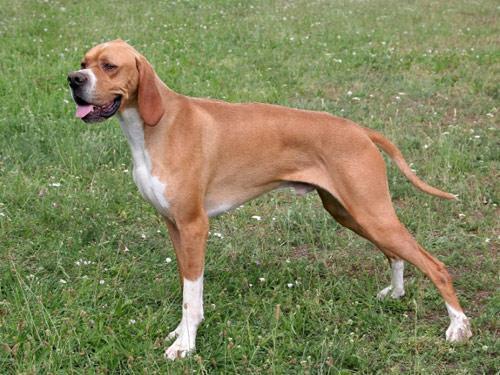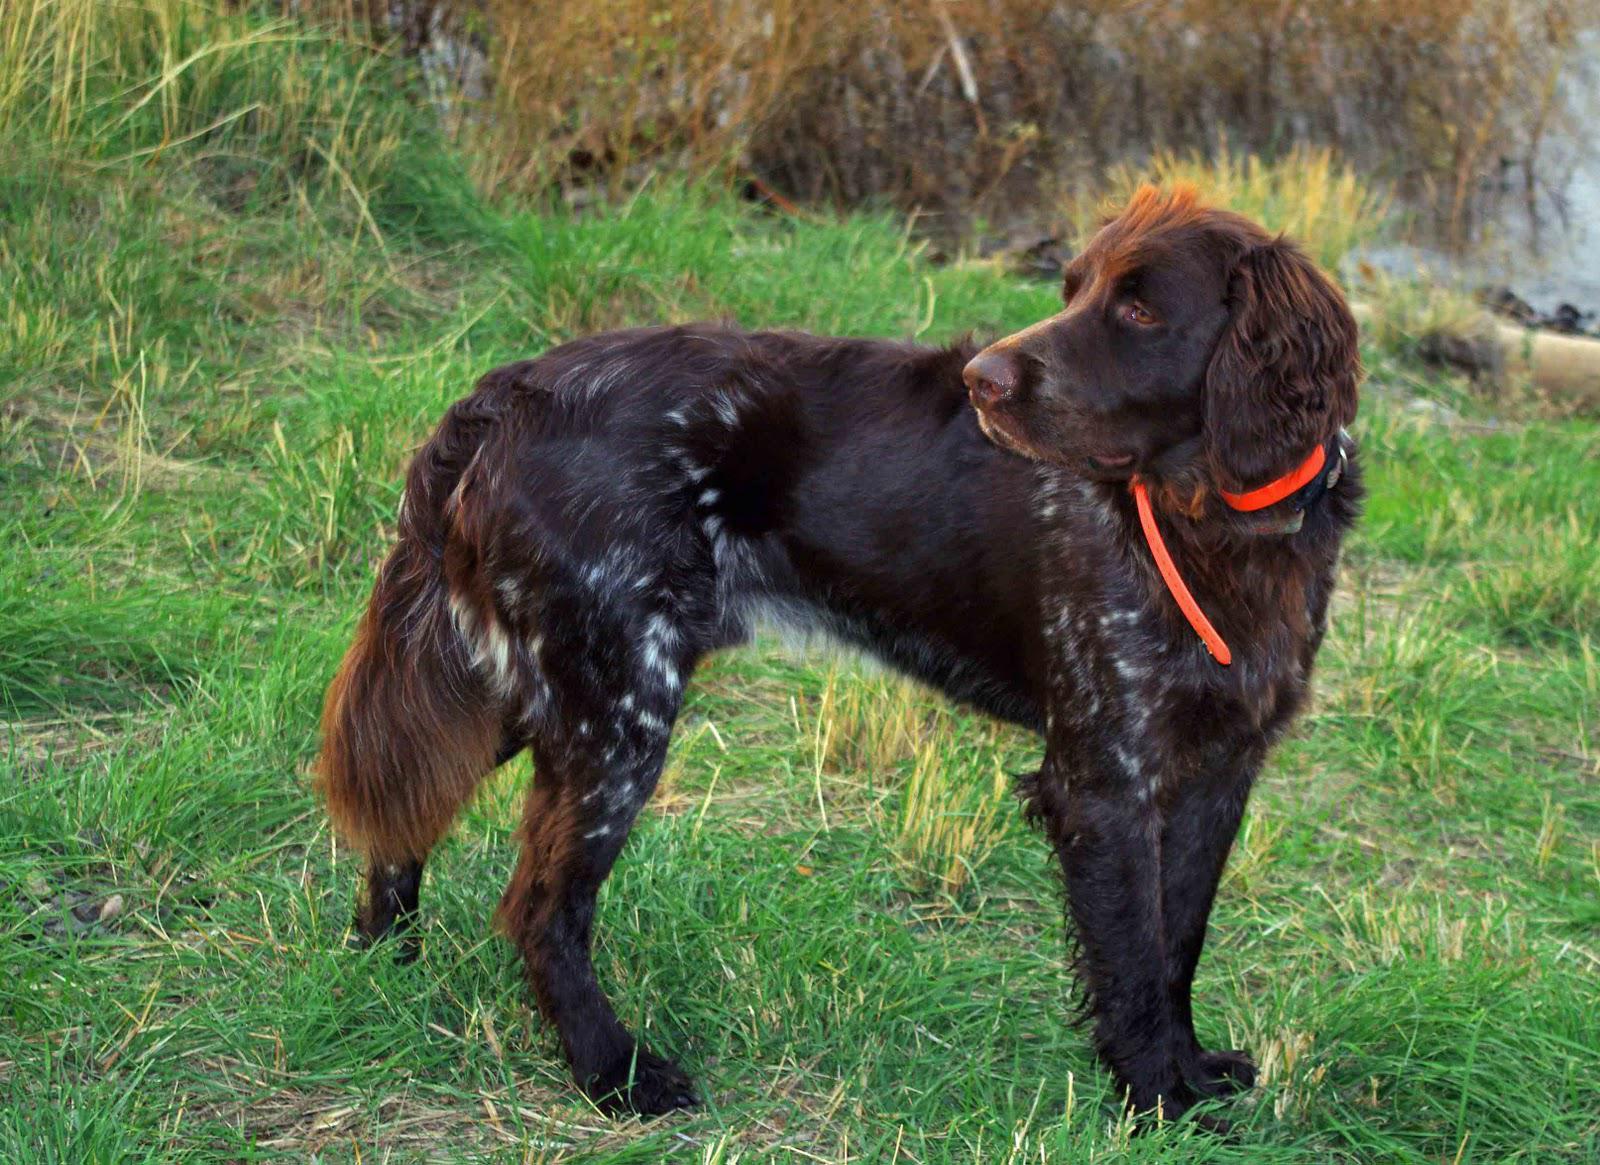The first image is the image on the left, the second image is the image on the right. For the images displayed, is the sentence "The left image features a solid-colored hound in leftward-facing profile with its tail extended out." factually correct? Answer yes or no. No. The first image is the image on the left, the second image is the image on the right. Evaluate the accuracy of this statement regarding the images: "The dog in the image on the left is wearing a collar.". Is it true? Answer yes or no. No. 